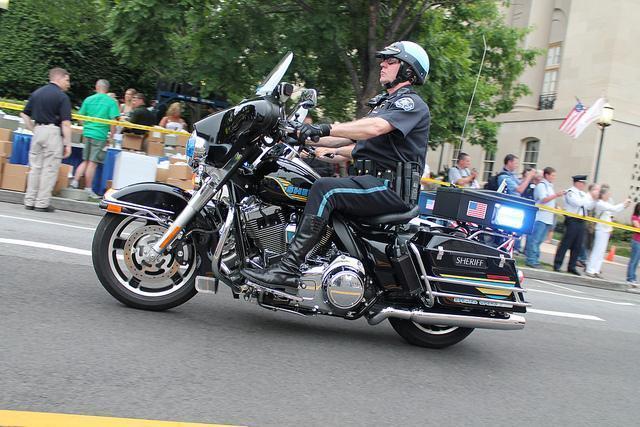What is the name of the nation with the flag in this picture?
Indicate the correct response by choosing from the four available options to answer the question.
Options: United kingdom, south korea, canada, united states. United states. 